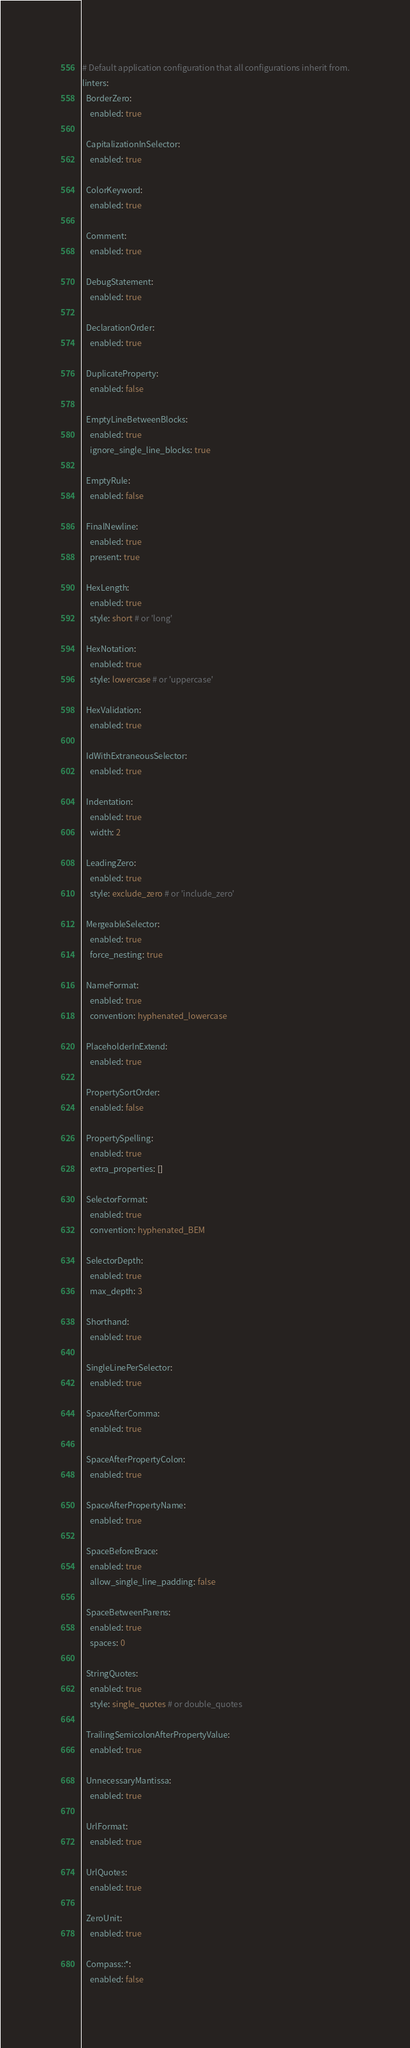<code> <loc_0><loc_0><loc_500><loc_500><_YAML_># Default application configuration that all configurations inherit from.
linters:
  BorderZero:
    enabled: true

  CapitalizationInSelector:
    enabled: true

  ColorKeyword:
    enabled: true

  Comment:
    enabled: true

  DebugStatement:
    enabled: true

  DeclarationOrder:
    enabled: true

  DuplicateProperty:
    enabled: false

  EmptyLineBetweenBlocks:
    enabled: true
    ignore_single_line_blocks: true

  EmptyRule:
    enabled: false

  FinalNewline:
    enabled: true
    present: true

  HexLength:
    enabled: true
    style: short # or 'long'

  HexNotation:
    enabled: true
    style: lowercase # or 'uppercase'

  HexValidation:
    enabled: true

  IdWithExtraneousSelector:
    enabled: true

  Indentation:
    enabled: true
    width: 2

  LeadingZero:
    enabled: true
    style: exclude_zero # or 'include_zero'

  MergeableSelector:
    enabled: true
    force_nesting: true

  NameFormat:
    enabled: true
    convention: hyphenated_lowercase

  PlaceholderInExtend:
    enabled: true

  PropertySortOrder:
    enabled: false

  PropertySpelling:
    enabled: true
    extra_properties: []

  SelectorFormat:
    enabled: true
    convention: hyphenated_BEM

  SelectorDepth:
    enabled: true
    max_depth: 3

  Shorthand:
    enabled: true

  SingleLinePerSelector:
    enabled: true

  SpaceAfterComma:
    enabled: true

  SpaceAfterPropertyColon:
    enabled: true

  SpaceAfterPropertyName:
    enabled: true

  SpaceBeforeBrace:
    enabled: true
    allow_single_line_padding: false

  SpaceBetweenParens:
    enabled: true
    spaces: 0

  StringQuotes:
    enabled: true
    style: single_quotes # or double_quotes

  TrailingSemicolonAfterPropertyValue:
    enabled: true

  UnnecessaryMantissa:
    enabled: true

  UrlFormat:
    enabled: true

  UrlQuotes:
    enabled: true

  ZeroUnit:
    enabled: true

  Compass::*:
    enabled: false
</code> 